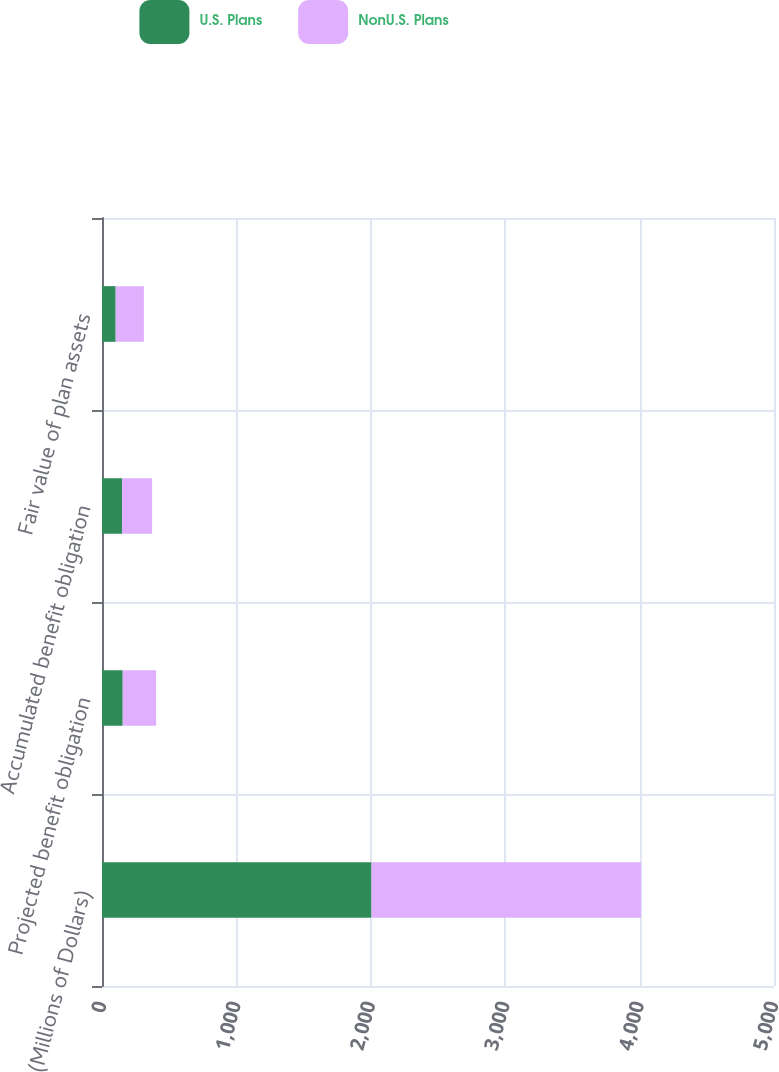Convert chart. <chart><loc_0><loc_0><loc_500><loc_500><stacked_bar_chart><ecel><fcel>(Millions of Dollars)<fcel>Projected benefit obligation<fcel>Accumulated benefit obligation<fcel>Fair value of plan assets<nl><fcel>U.S. Plans<fcel>2005<fcel>154.2<fcel>148.7<fcel>101.8<nl><fcel>NonU.S. Plans<fcel>2005<fcel>248.6<fcel>224.2<fcel>209.7<nl></chart> 